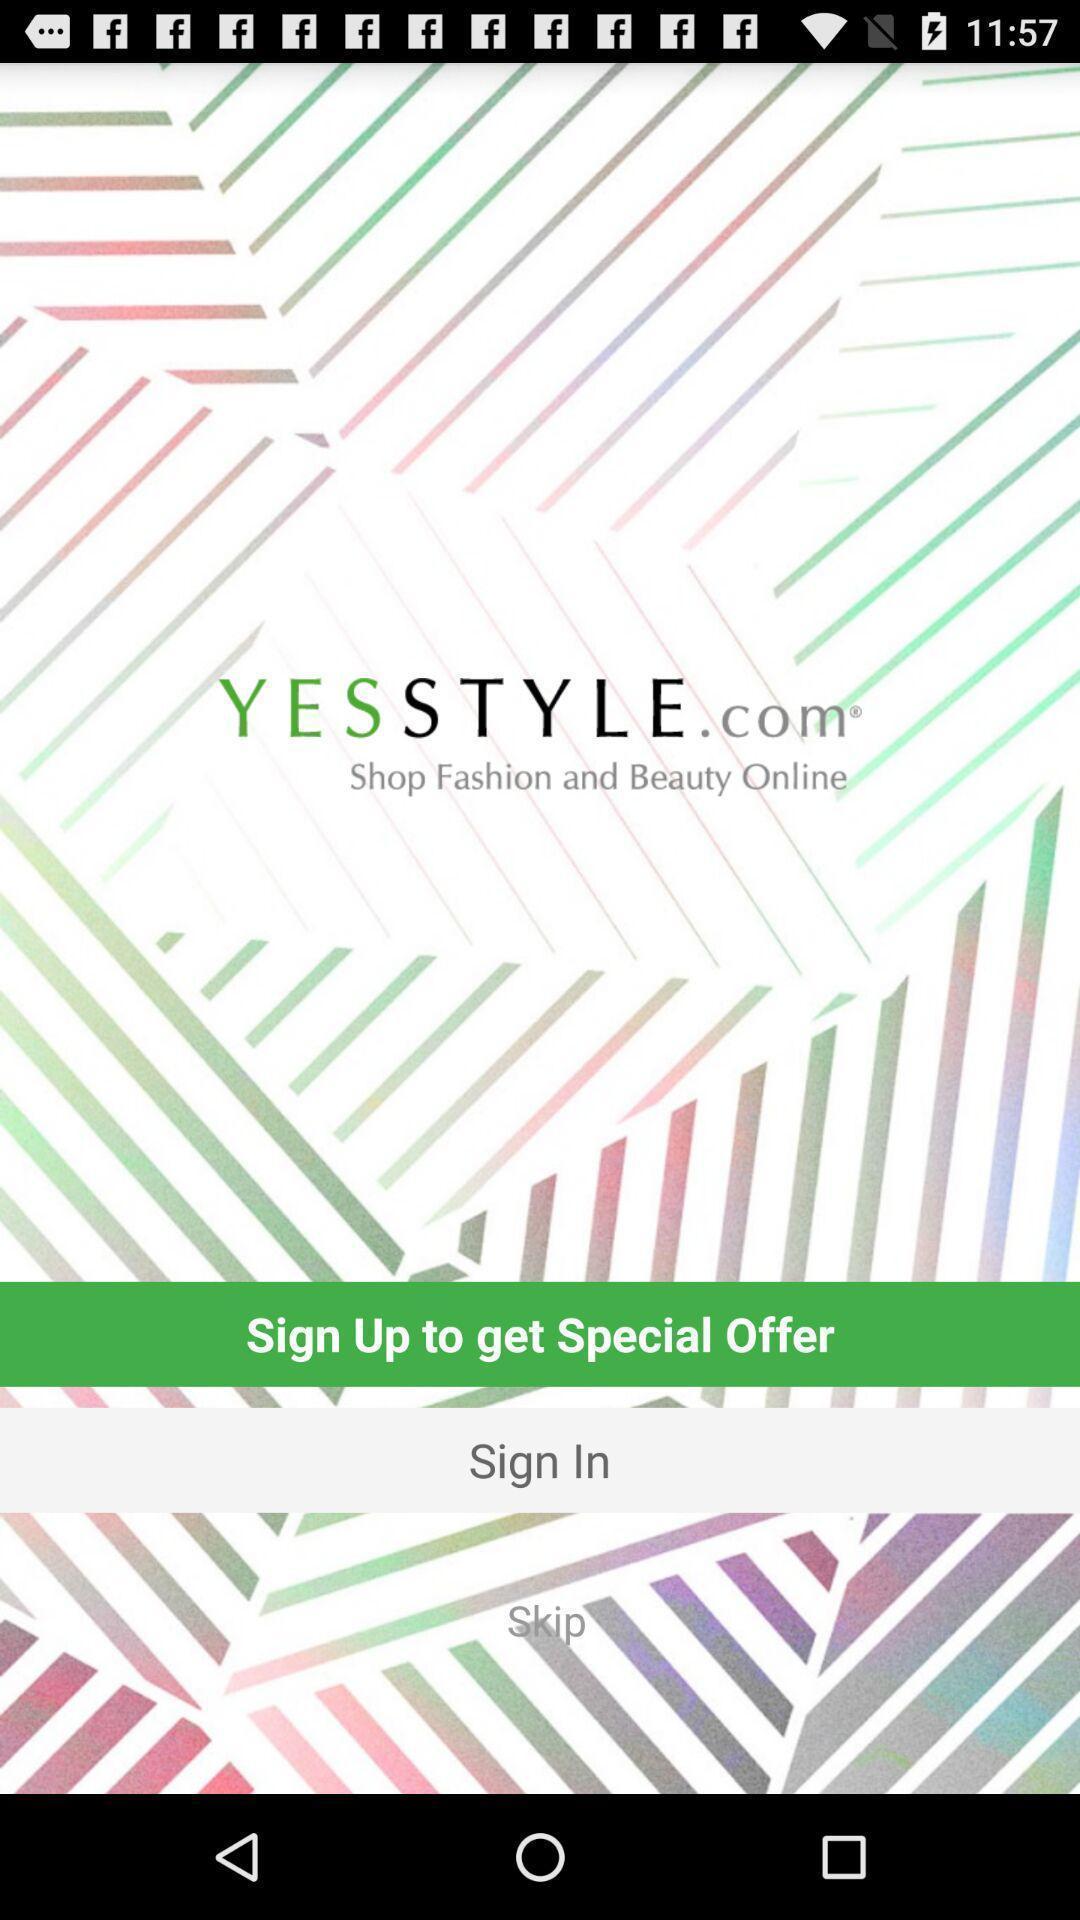Describe this image in words. Welcome page. 